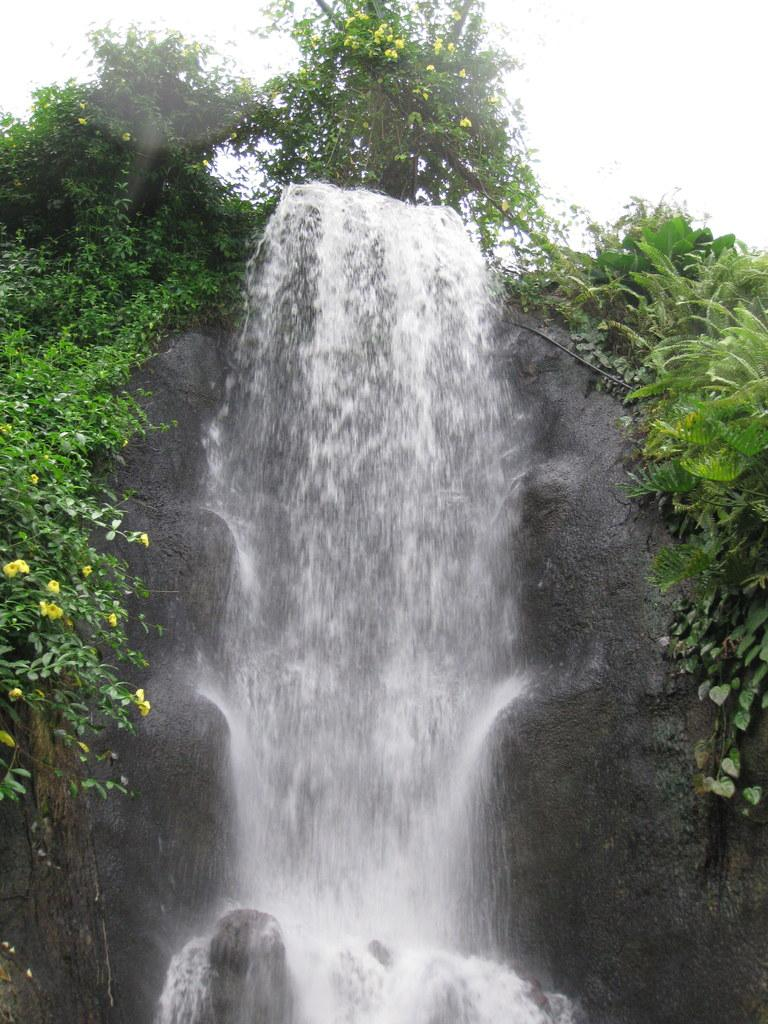What type of vegetation can be seen in the image? There are plants and grass in the image. Can you describe the tree in the image? There is a tree at the top of the image. What part of the natural environment is visible in the image? The sky is visible in the top right of the image. What type of crate is being used to store the manager's coat in the image? There is no crate or manager's coat present in the image. 